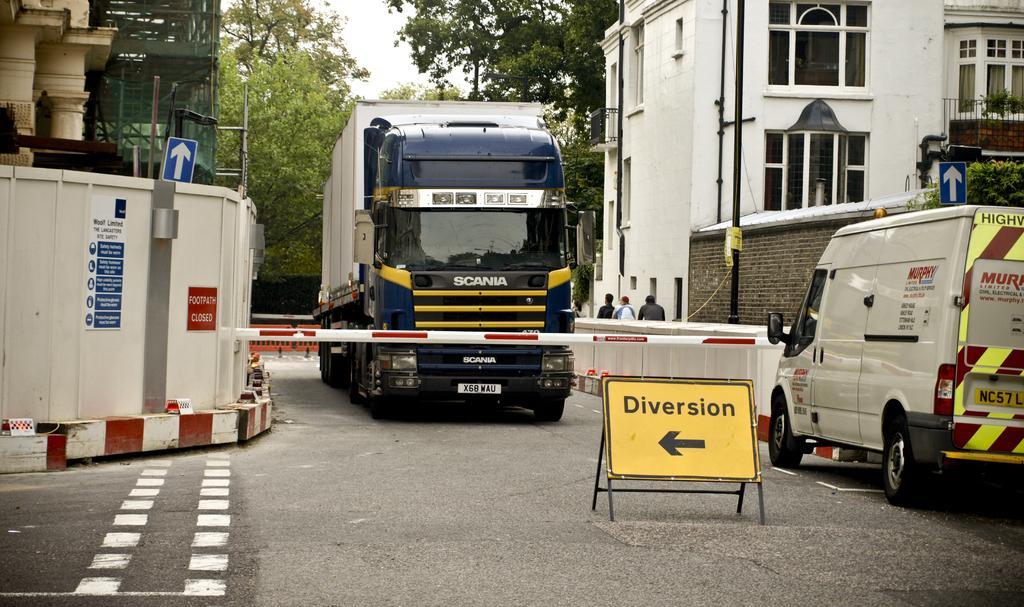Please provide a concise description of this image. In this image we can see vehicles on the road, three persons standing near the wall and there are sign boards, buildings and posters to the wall, an iron pole, few trees and the sky in the background. 